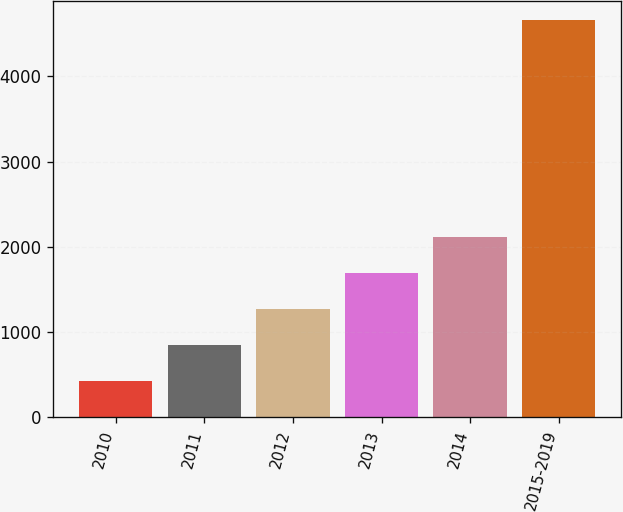<chart> <loc_0><loc_0><loc_500><loc_500><bar_chart><fcel>2010<fcel>2011<fcel>2012<fcel>2013<fcel>2014<fcel>2015-2019<nl><fcel>432<fcel>854.2<fcel>1276.4<fcel>1698.6<fcel>2120.8<fcel>4654<nl></chart> 